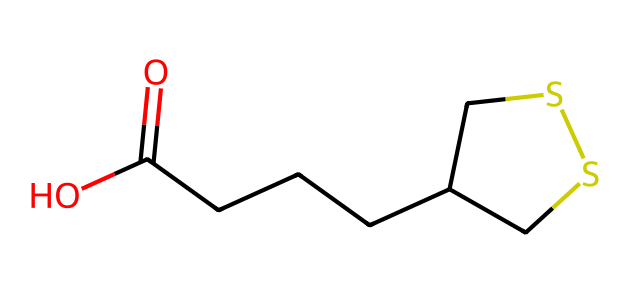What is the total number of carbon atoms in alpha-lipoic acid? By examining the SMILES representation, we can count the carbon (C) atoms. The structure includes 8 carbon atoms found in the chain and ring structure.
Answer: 8 How many sulfur atoms are present in alpha-lipoic acid? In the SMILES representation, we can locate the sulfur (S) atoms. There are 2 sulfur atoms visible in the structure.
Answer: 2 What is the functional group present in alpha-lipoic acid? Looking at the SMILES representation, we can identify the carboxylic acid functional group indicated by the sequence O=C(O) located at one end of the molecule.
Answer: carboxylic acid What type of compound is alpha-lipoic acid classified as? Based on its properties and structure, specifically the presence of a thiol group (from the sulfur atoms) and antioxidant activity, alpha-lipoic acid is classified as a thiol antioxidant.
Answer: thiol antioxidant How does the presence of sulfur contribute to the activity of alpha-lipoic acid? The sulfur atoms in the compound can form disulfide bonds and reduce oxidative stress, which enhances its role as an antioxidant. Additionally, they are vital for regeneration of other antioxidants, making it versatile.
Answer: enhances antioxidant activity Does alpha-lipoic acid exhibit amphipathic properties? Yes, due to the presence of both hydrophobic carbon chains and hydrophilic carboxylic acid groups. These different sections allow it to interact with both water and lipid environments.
Answer: yes 